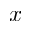<formula> <loc_0><loc_0><loc_500><loc_500>x</formula> 